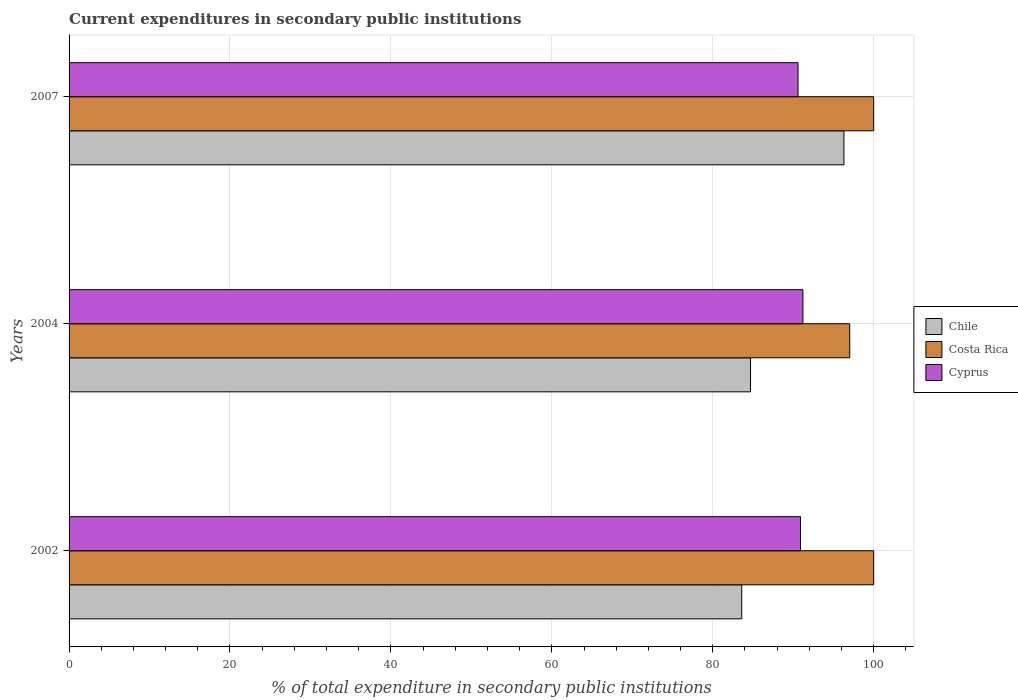How many different coloured bars are there?
Keep it short and to the point. 3. How many groups of bars are there?
Make the answer very short. 3. Are the number of bars per tick equal to the number of legend labels?
Offer a very short reply. Yes. What is the label of the 3rd group of bars from the top?
Your answer should be very brief. 2002. Across all years, what is the minimum current expenditures in secondary public institutions in Chile?
Your response must be concise. 83.6. What is the total current expenditures in secondary public institutions in Costa Rica in the graph?
Keep it short and to the point. 297.03. What is the difference between the current expenditures in secondary public institutions in Cyprus in 2002 and that in 2007?
Your answer should be very brief. 0.31. What is the difference between the current expenditures in secondary public institutions in Cyprus in 2007 and the current expenditures in secondary public institutions in Chile in 2002?
Your response must be concise. 7. What is the average current expenditures in secondary public institutions in Costa Rica per year?
Offer a very short reply. 99.01. In the year 2002, what is the difference between the current expenditures in secondary public institutions in Chile and current expenditures in secondary public institutions in Costa Rica?
Ensure brevity in your answer.  -16.4. In how many years, is the current expenditures in secondary public institutions in Costa Rica greater than 88 %?
Provide a succinct answer. 3. What is the ratio of the current expenditures in secondary public institutions in Cyprus in 2002 to that in 2004?
Your answer should be very brief. 1. Is the current expenditures in secondary public institutions in Cyprus in 2002 less than that in 2004?
Keep it short and to the point. Yes. Is the difference between the current expenditures in secondary public institutions in Chile in 2002 and 2007 greater than the difference between the current expenditures in secondary public institutions in Costa Rica in 2002 and 2007?
Ensure brevity in your answer.  No. What is the difference between the highest and the second highest current expenditures in secondary public institutions in Cyprus?
Provide a short and direct response. 0.3. What is the difference between the highest and the lowest current expenditures in secondary public institutions in Chile?
Offer a very short reply. 12.7. In how many years, is the current expenditures in secondary public institutions in Chile greater than the average current expenditures in secondary public institutions in Chile taken over all years?
Your response must be concise. 1. Is the sum of the current expenditures in secondary public institutions in Cyprus in 2004 and 2007 greater than the maximum current expenditures in secondary public institutions in Costa Rica across all years?
Offer a very short reply. Yes. What does the 1st bar from the top in 2002 represents?
Make the answer very short. Cyprus. What does the 3rd bar from the bottom in 2004 represents?
Provide a short and direct response. Cyprus. How many bars are there?
Your answer should be very brief. 9. Are the values on the major ticks of X-axis written in scientific E-notation?
Your answer should be compact. No. Does the graph contain any zero values?
Offer a terse response. No. Where does the legend appear in the graph?
Provide a succinct answer. Center right. How many legend labels are there?
Your response must be concise. 3. How are the legend labels stacked?
Your response must be concise. Vertical. What is the title of the graph?
Provide a short and direct response. Current expenditures in secondary public institutions. Does "Sub-Saharan Africa (developing only)" appear as one of the legend labels in the graph?
Keep it short and to the point. No. What is the label or title of the X-axis?
Provide a succinct answer. % of total expenditure in secondary public institutions. What is the label or title of the Y-axis?
Offer a terse response. Years. What is the % of total expenditure in secondary public institutions of Chile in 2002?
Your answer should be compact. 83.6. What is the % of total expenditure in secondary public institutions of Costa Rica in 2002?
Offer a terse response. 100. What is the % of total expenditure in secondary public institutions in Cyprus in 2002?
Your answer should be compact. 90.91. What is the % of total expenditure in secondary public institutions in Chile in 2004?
Your answer should be very brief. 84.69. What is the % of total expenditure in secondary public institutions of Costa Rica in 2004?
Offer a terse response. 97.03. What is the % of total expenditure in secondary public institutions of Cyprus in 2004?
Your answer should be compact. 91.21. What is the % of total expenditure in secondary public institutions of Chile in 2007?
Ensure brevity in your answer.  96.31. What is the % of total expenditure in secondary public institutions in Cyprus in 2007?
Make the answer very short. 90.6. Across all years, what is the maximum % of total expenditure in secondary public institutions of Chile?
Make the answer very short. 96.31. Across all years, what is the maximum % of total expenditure in secondary public institutions of Cyprus?
Provide a short and direct response. 91.21. Across all years, what is the minimum % of total expenditure in secondary public institutions of Chile?
Keep it short and to the point. 83.6. Across all years, what is the minimum % of total expenditure in secondary public institutions of Costa Rica?
Your answer should be very brief. 97.03. Across all years, what is the minimum % of total expenditure in secondary public institutions in Cyprus?
Offer a very short reply. 90.6. What is the total % of total expenditure in secondary public institutions in Chile in the graph?
Make the answer very short. 264.6. What is the total % of total expenditure in secondary public institutions in Costa Rica in the graph?
Your answer should be compact. 297.03. What is the total % of total expenditure in secondary public institutions in Cyprus in the graph?
Ensure brevity in your answer.  272.72. What is the difference between the % of total expenditure in secondary public institutions in Chile in 2002 and that in 2004?
Offer a very short reply. -1.09. What is the difference between the % of total expenditure in secondary public institutions of Costa Rica in 2002 and that in 2004?
Your answer should be very brief. 2.97. What is the difference between the % of total expenditure in secondary public institutions of Cyprus in 2002 and that in 2004?
Offer a very short reply. -0.3. What is the difference between the % of total expenditure in secondary public institutions of Chile in 2002 and that in 2007?
Provide a short and direct response. -12.7. What is the difference between the % of total expenditure in secondary public institutions of Cyprus in 2002 and that in 2007?
Your response must be concise. 0.31. What is the difference between the % of total expenditure in secondary public institutions in Chile in 2004 and that in 2007?
Your answer should be very brief. -11.61. What is the difference between the % of total expenditure in secondary public institutions in Costa Rica in 2004 and that in 2007?
Provide a succinct answer. -2.97. What is the difference between the % of total expenditure in secondary public institutions in Cyprus in 2004 and that in 2007?
Give a very brief answer. 0.6. What is the difference between the % of total expenditure in secondary public institutions of Chile in 2002 and the % of total expenditure in secondary public institutions of Costa Rica in 2004?
Give a very brief answer. -13.42. What is the difference between the % of total expenditure in secondary public institutions of Chile in 2002 and the % of total expenditure in secondary public institutions of Cyprus in 2004?
Offer a terse response. -7.6. What is the difference between the % of total expenditure in secondary public institutions in Costa Rica in 2002 and the % of total expenditure in secondary public institutions in Cyprus in 2004?
Provide a short and direct response. 8.79. What is the difference between the % of total expenditure in secondary public institutions in Chile in 2002 and the % of total expenditure in secondary public institutions in Costa Rica in 2007?
Give a very brief answer. -16.4. What is the difference between the % of total expenditure in secondary public institutions of Chile in 2002 and the % of total expenditure in secondary public institutions of Cyprus in 2007?
Offer a terse response. -7. What is the difference between the % of total expenditure in secondary public institutions of Costa Rica in 2002 and the % of total expenditure in secondary public institutions of Cyprus in 2007?
Your answer should be very brief. 9.4. What is the difference between the % of total expenditure in secondary public institutions in Chile in 2004 and the % of total expenditure in secondary public institutions in Costa Rica in 2007?
Your answer should be compact. -15.31. What is the difference between the % of total expenditure in secondary public institutions in Chile in 2004 and the % of total expenditure in secondary public institutions in Cyprus in 2007?
Provide a short and direct response. -5.91. What is the difference between the % of total expenditure in secondary public institutions in Costa Rica in 2004 and the % of total expenditure in secondary public institutions in Cyprus in 2007?
Offer a very short reply. 6.42. What is the average % of total expenditure in secondary public institutions in Chile per year?
Provide a short and direct response. 88.2. What is the average % of total expenditure in secondary public institutions of Costa Rica per year?
Provide a short and direct response. 99.01. What is the average % of total expenditure in secondary public institutions in Cyprus per year?
Your answer should be very brief. 90.91. In the year 2002, what is the difference between the % of total expenditure in secondary public institutions of Chile and % of total expenditure in secondary public institutions of Costa Rica?
Your answer should be very brief. -16.4. In the year 2002, what is the difference between the % of total expenditure in secondary public institutions of Chile and % of total expenditure in secondary public institutions of Cyprus?
Make the answer very short. -7.31. In the year 2002, what is the difference between the % of total expenditure in secondary public institutions in Costa Rica and % of total expenditure in secondary public institutions in Cyprus?
Ensure brevity in your answer.  9.09. In the year 2004, what is the difference between the % of total expenditure in secondary public institutions in Chile and % of total expenditure in secondary public institutions in Costa Rica?
Ensure brevity in your answer.  -12.33. In the year 2004, what is the difference between the % of total expenditure in secondary public institutions in Chile and % of total expenditure in secondary public institutions in Cyprus?
Keep it short and to the point. -6.51. In the year 2004, what is the difference between the % of total expenditure in secondary public institutions in Costa Rica and % of total expenditure in secondary public institutions in Cyprus?
Your response must be concise. 5.82. In the year 2007, what is the difference between the % of total expenditure in secondary public institutions in Chile and % of total expenditure in secondary public institutions in Costa Rica?
Your response must be concise. -3.69. In the year 2007, what is the difference between the % of total expenditure in secondary public institutions of Chile and % of total expenditure in secondary public institutions of Cyprus?
Ensure brevity in your answer.  5.7. In the year 2007, what is the difference between the % of total expenditure in secondary public institutions of Costa Rica and % of total expenditure in secondary public institutions of Cyprus?
Make the answer very short. 9.4. What is the ratio of the % of total expenditure in secondary public institutions in Chile in 2002 to that in 2004?
Your response must be concise. 0.99. What is the ratio of the % of total expenditure in secondary public institutions in Costa Rica in 2002 to that in 2004?
Offer a terse response. 1.03. What is the ratio of the % of total expenditure in secondary public institutions of Chile in 2002 to that in 2007?
Give a very brief answer. 0.87. What is the ratio of the % of total expenditure in secondary public institutions in Cyprus in 2002 to that in 2007?
Provide a succinct answer. 1. What is the ratio of the % of total expenditure in secondary public institutions of Chile in 2004 to that in 2007?
Give a very brief answer. 0.88. What is the ratio of the % of total expenditure in secondary public institutions in Costa Rica in 2004 to that in 2007?
Offer a very short reply. 0.97. What is the ratio of the % of total expenditure in secondary public institutions of Cyprus in 2004 to that in 2007?
Give a very brief answer. 1.01. What is the difference between the highest and the second highest % of total expenditure in secondary public institutions in Chile?
Your answer should be very brief. 11.61. What is the difference between the highest and the second highest % of total expenditure in secondary public institutions of Cyprus?
Your answer should be compact. 0.3. What is the difference between the highest and the lowest % of total expenditure in secondary public institutions in Chile?
Your answer should be compact. 12.7. What is the difference between the highest and the lowest % of total expenditure in secondary public institutions in Costa Rica?
Give a very brief answer. 2.97. What is the difference between the highest and the lowest % of total expenditure in secondary public institutions in Cyprus?
Give a very brief answer. 0.6. 